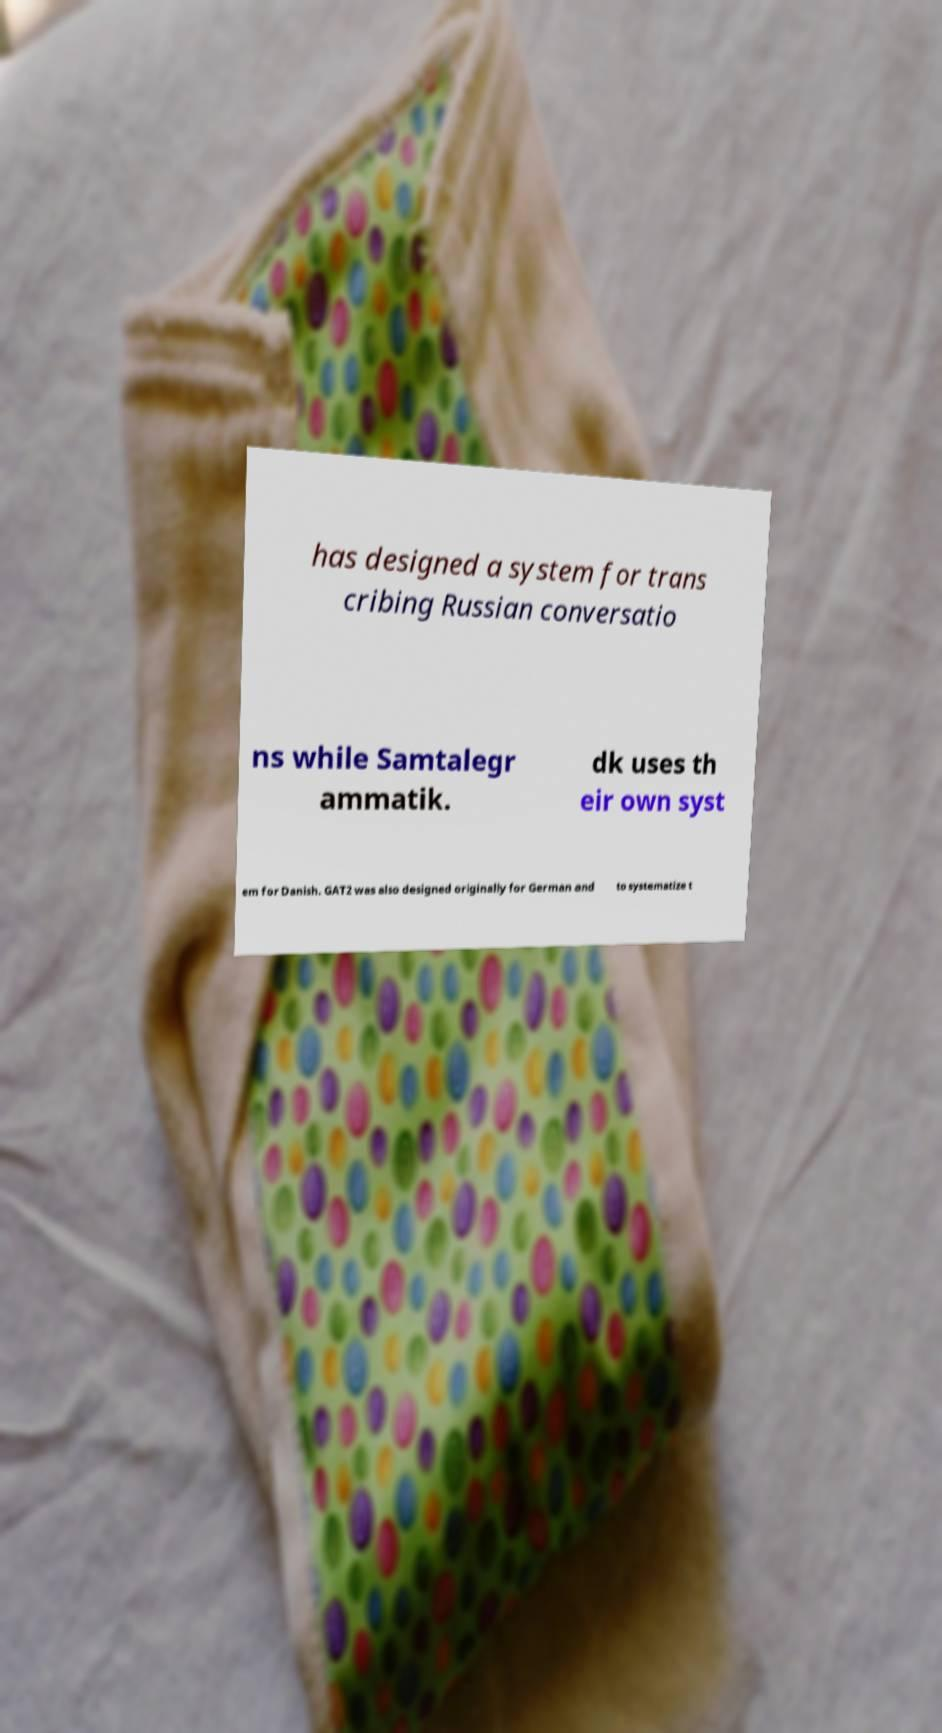I need the written content from this picture converted into text. Can you do that? has designed a system for trans cribing Russian conversatio ns while Samtalegr ammatik. dk uses th eir own syst em for Danish. GAT2 was also designed originally for German and to systematize t 